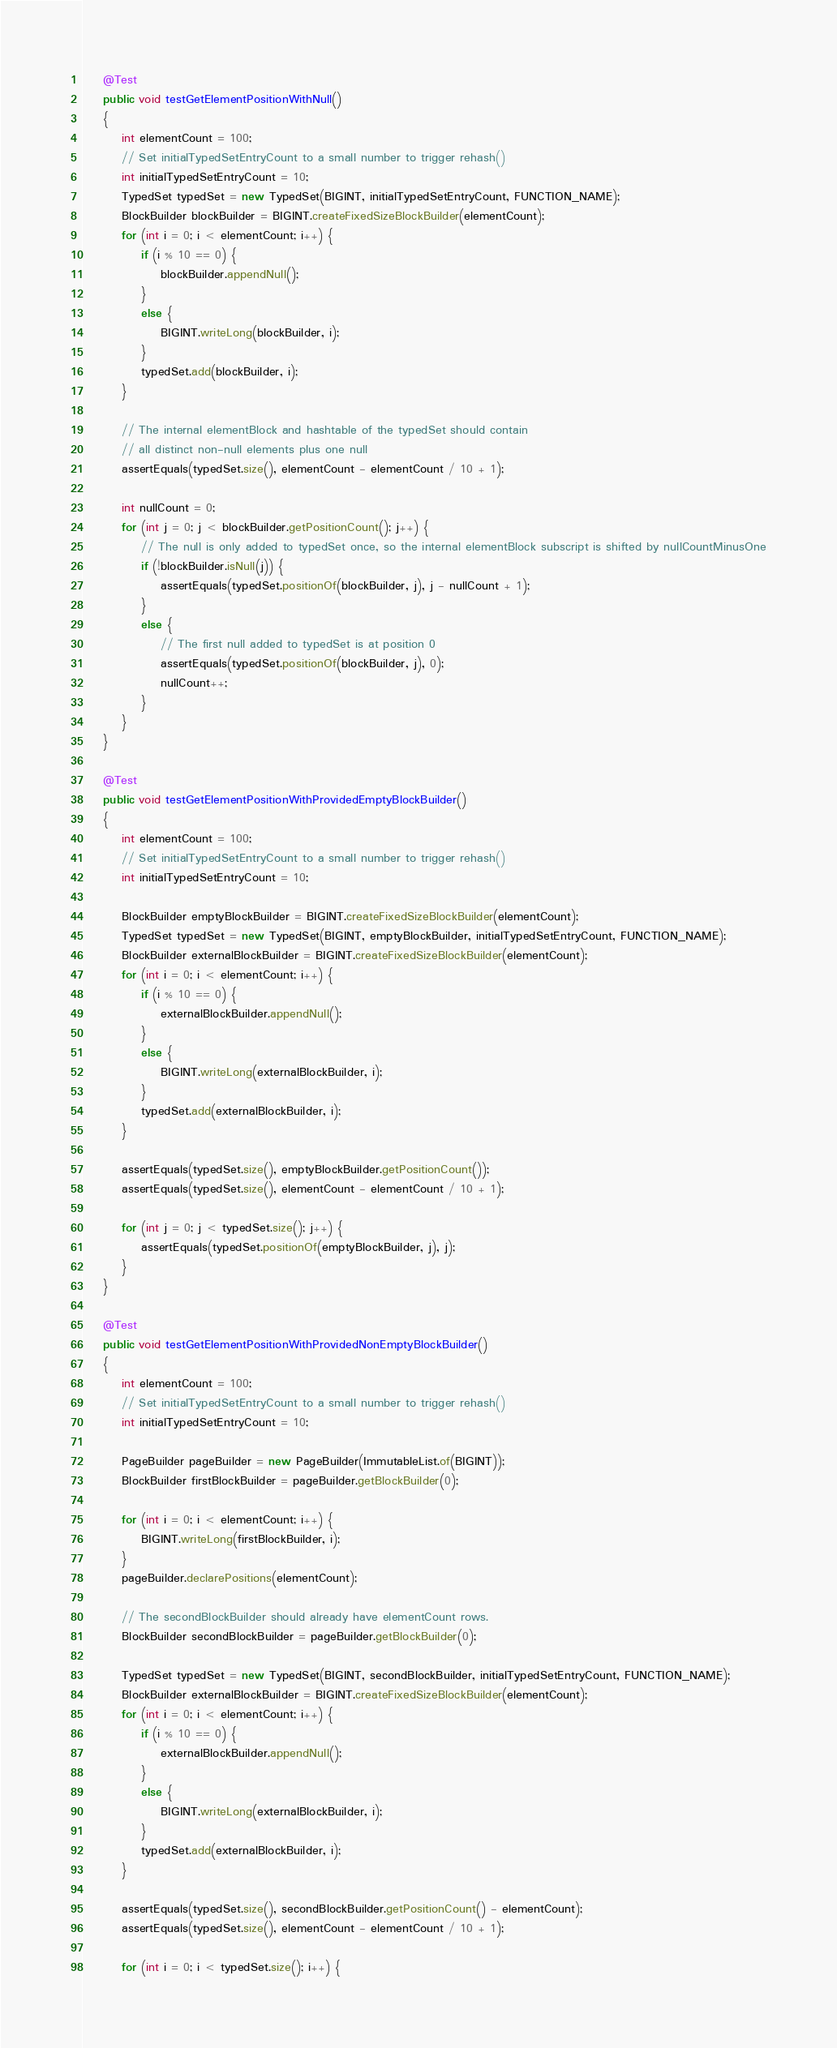Convert code to text. <code><loc_0><loc_0><loc_500><loc_500><_Java_>    @Test
    public void testGetElementPositionWithNull()
    {
        int elementCount = 100;
        // Set initialTypedSetEntryCount to a small number to trigger rehash()
        int initialTypedSetEntryCount = 10;
        TypedSet typedSet = new TypedSet(BIGINT, initialTypedSetEntryCount, FUNCTION_NAME);
        BlockBuilder blockBuilder = BIGINT.createFixedSizeBlockBuilder(elementCount);
        for (int i = 0; i < elementCount; i++) {
            if (i % 10 == 0) {
                blockBuilder.appendNull();
            }
            else {
                BIGINT.writeLong(blockBuilder, i);
            }
            typedSet.add(blockBuilder, i);
        }

        // The internal elementBlock and hashtable of the typedSet should contain
        // all distinct non-null elements plus one null
        assertEquals(typedSet.size(), elementCount - elementCount / 10 + 1);

        int nullCount = 0;
        for (int j = 0; j < blockBuilder.getPositionCount(); j++) {
            // The null is only added to typedSet once, so the internal elementBlock subscript is shifted by nullCountMinusOne
            if (!blockBuilder.isNull(j)) {
                assertEquals(typedSet.positionOf(blockBuilder, j), j - nullCount + 1);
            }
            else {
                // The first null added to typedSet is at position 0
                assertEquals(typedSet.positionOf(blockBuilder, j), 0);
                nullCount++;
            }
        }
    }

    @Test
    public void testGetElementPositionWithProvidedEmptyBlockBuilder()
    {
        int elementCount = 100;
        // Set initialTypedSetEntryCount to a small number to trigger rehash()
        int initialTypedSetEntryCount = 10;

        BlockBuilder emptyBlockBuilder = BIGINT.createFixedSizeBlockBuilder(elementCount);
        TypedSet typedSet = new TypedSet(BIGINT, emptyBlockBuilder, initialTypedSetEntryCount, FUNCTION_NAME);
        BlockBuilder externalBlockBuilder = BIGINT.createFixedSizeBlockBuilder(elementCount);
        for (int i = 0; i < elementCount; i++) {
            if (i % 10 == 0) {
                externalBlockBuilder.appendNull();
            }
            else {
                BIGINT.writeLong(externalBlockBuilder, i);
            }
            typedSet.add(externalBlockBuilder, i);
        }

        assertEquals(typedSet.size(), emptyBlockBuilder.getPositionCount());
        assertEquals(typedSet.size(), elementCount - elementCount / 10 + 1);

        for (int j = 0; j < typedSet.size(); j++) {
            assertEquals(typedSet.positionOf(emptyBlockBuilder, j), j);
        }
    }

    @Test
    public void testGetElementPositionWithProvidedNonEmptyBlockBuilder()
    {
        int elementCount = 100;
        // Set initialTypedSetEntryCount to a small number to trigger rehash()
        int initialTypedSetEntryCount = 10;

        PageBuilder pageBuilder = new PageBuilder(ImmutableList.of(BIGINT));
        BlockBuilder firstBlockBuilder = pageBuilder.getBlockBuilder(0);

        for (int i = 0; i < elementCount; i++) {
            BIGINT.writeLong(firstBlockBuilder, i);
        }
        pageBuilder.declarePositions(elementCount);

        // The secondBlockBuilder should already have elementCount rows.
        BlockBuilder secondBlockBuilder = pageBuilder.getBlockBuilder(0);

        TypedSet typedSet = new TypedSet(BIGINT, secondBlockBuilder, initialTypedSetEntryCount, FUNCTION_NAME);
        BlockBuilder externalBlockBuilder = BIGINT.createFixedSizeBlockBuilder(elementCount);
        for (int i = 0; i < elementCount; i++) {
            if (i % 10 == 0) {
                externalBlockBuilder.appendNull();
            }
            else {
                BIGINT.writeLong(externalBlockBuilder, i);
            }
            typedSet.add(externalBlockBuilder, i);
        }

        assertEquals(typedSet.size(), secondBlockBuilder.getPositionCount() - elementCount);
        assertEquals(typedSet.size(), elementCount - elementCount / 10 + 1);

        for (int i = 0; i < typedSet.size(); i++) {</code> 